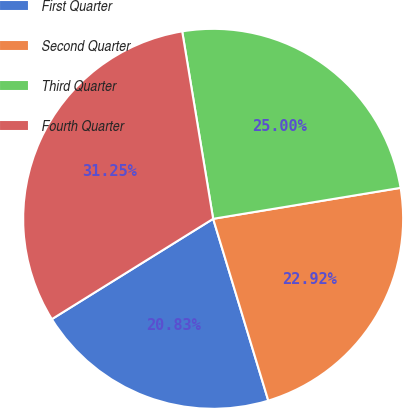Convert chart. <chart><loc_0><loc_0><loc_500><loc_500><pie_chart><fcel>First Quarter<fcel>Second Quarter<fcel>Third Quarter<fcel>Fourth Quarter<nl><fcel>20.83%<fcel>22.92%<fcel>25.0%<fcel>31.25%<nl></chart> 